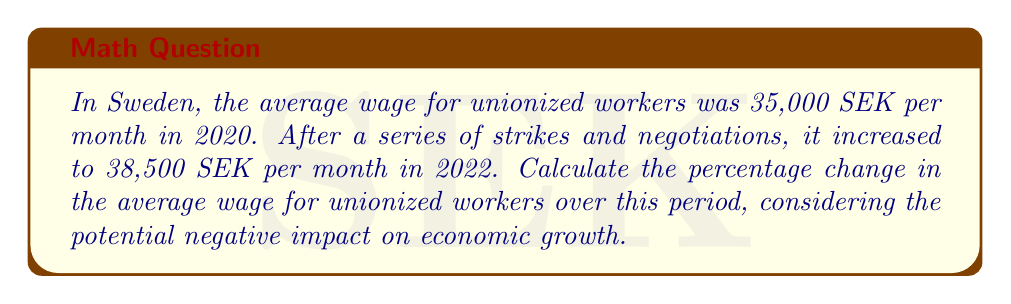Help me with this question. To calculate the percentage change in the average wage, we'll use the formula:

$$ \text{Percentage Change} = \frac{\text{New Value} - \text{Original Value}}{\text{Original Value}} \times 100\% $$

Let's plug in the values:

Original Value (2020 wage): 35,000 SEK
New Value (2022 wage): 38,500 SEK

$$ \text{Percentage Change} = \frac{38,500 - 35,000}{35,000} \times 100\% $$

$$ = \frac{3,500}{35,000} \times 100\% $$

$$ = 0.1 \times 100\% $$

$$ = 10\% $$

The average wage for unionized workers increased by 10% over the two-year period. While this may seem positive for workers, it's important to consider the potential negative impacts on economic growth, such as increased labor costs for businesses, reduced competitiveness, and possible job losses in non-unionized sectors.
Answer: 10% increase 